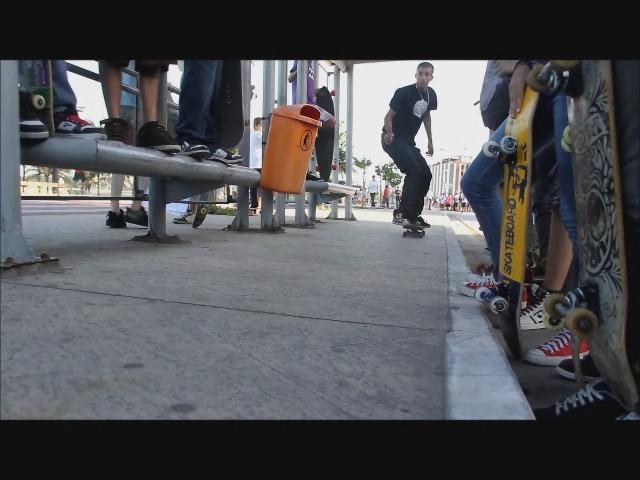What is the orange object used for? trash 